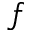<formula> <loc_0><loc_0><loc_500><loc_500>f</formula> 